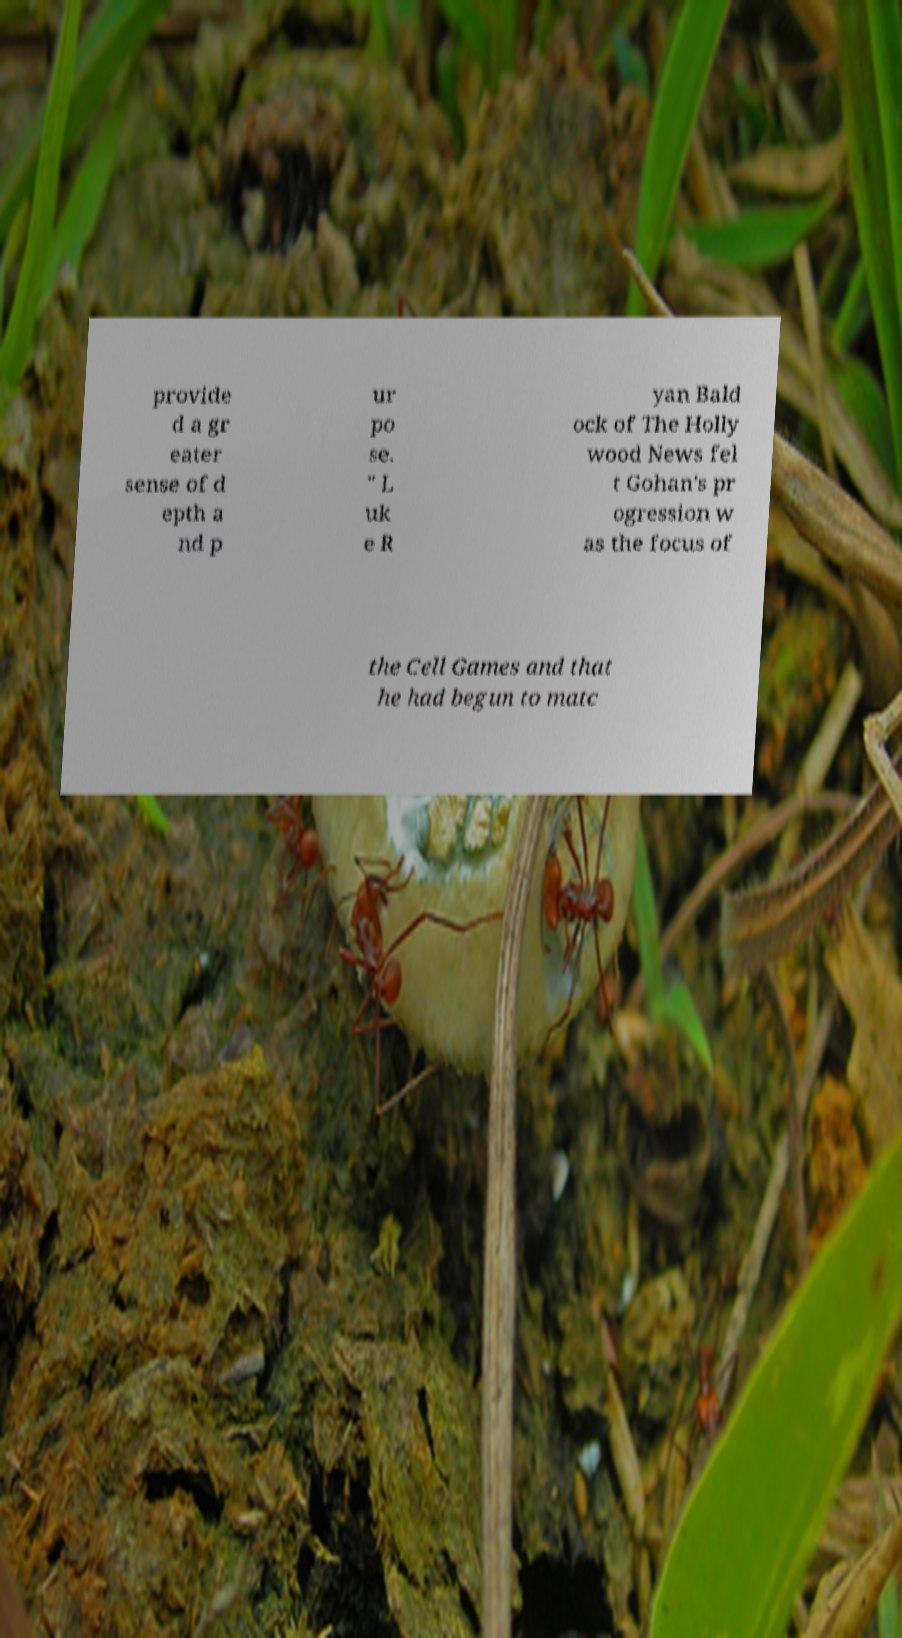Could you extract and type out the text from this image? provide d a gr eater sense of d epth a nd p ur po se. " L uk e R yan Bald ock of The Holly wood News fel t Gohan's pr ogression w as the focus of the Cell Games and that he had begun to matc 